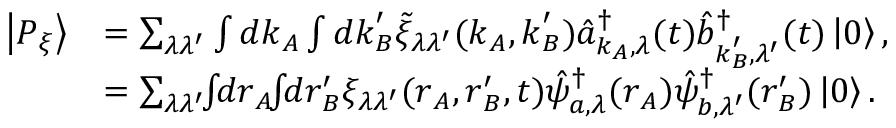<formula> <loc_0><loc_0><loc_500><loc_500>\begin{array} { r l } { \left | P _ { \xi } \right \rangle } & { = \sum _ { \lambda \lambda ^ { \prime } } \int d k _ { A } \int d k _ { B } ^ { \prime } \tilde { \xi } _ { \lambda \lambda ^ { \prime } } ( k _ { A } , k _ { B } ^ { \prime } ) \hat { a } _ { k _ { A } , \lambda } ^ { \dagger } ( t ) \hat { b } _ { k _ { B } ^ { \prime } , \lambda ^ { \prime } } ^ { \dagger } ( t ) \left | 0 \right \rangle , } \\ & { = \sum _ { \lambda \lambda ^ { \prime } } \, \int \, d r _ { A } \, \int \, d r _ { B } ^ { \prime } \xi _ { \lambda \lambda ^ { \prime } } ( r _ { A } , r _ { B } ^ { \prime } , t ) \hat { \psi } _ { a , \lambda } ^ { \dagger } ( r _ { A } ) \hat { \psi } _ { b , \lambda ^ { \prime } } ^ { \dagger } ( r _ { B } ^ { \prime } ) \left | 0 \right \rangle . } \end{array}</formula> 